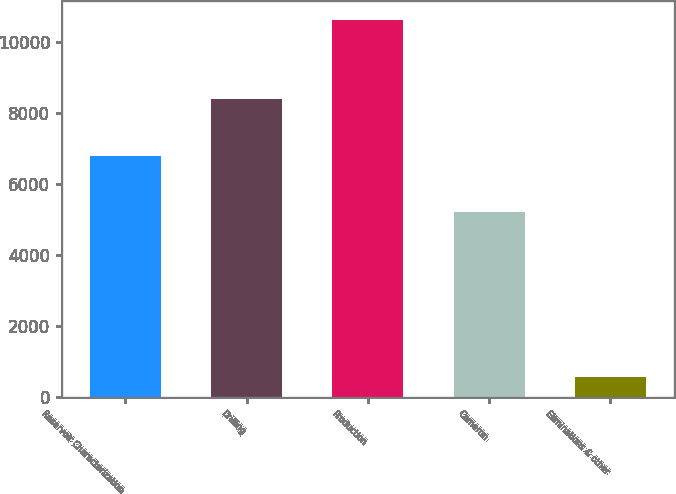Convert chart to OTSL. <chart><loc_0><loc_0><loc_500><loc_500><bar_chart><fcel>Reservoir Characterization<fcel>Drilling<fcel>Production<fcel>Cameron<fcel>Eliminations & other<nl><fcel>6795<fcel>8392<fcel>10630<fcel>5205<fcel>582<nl></chart> 